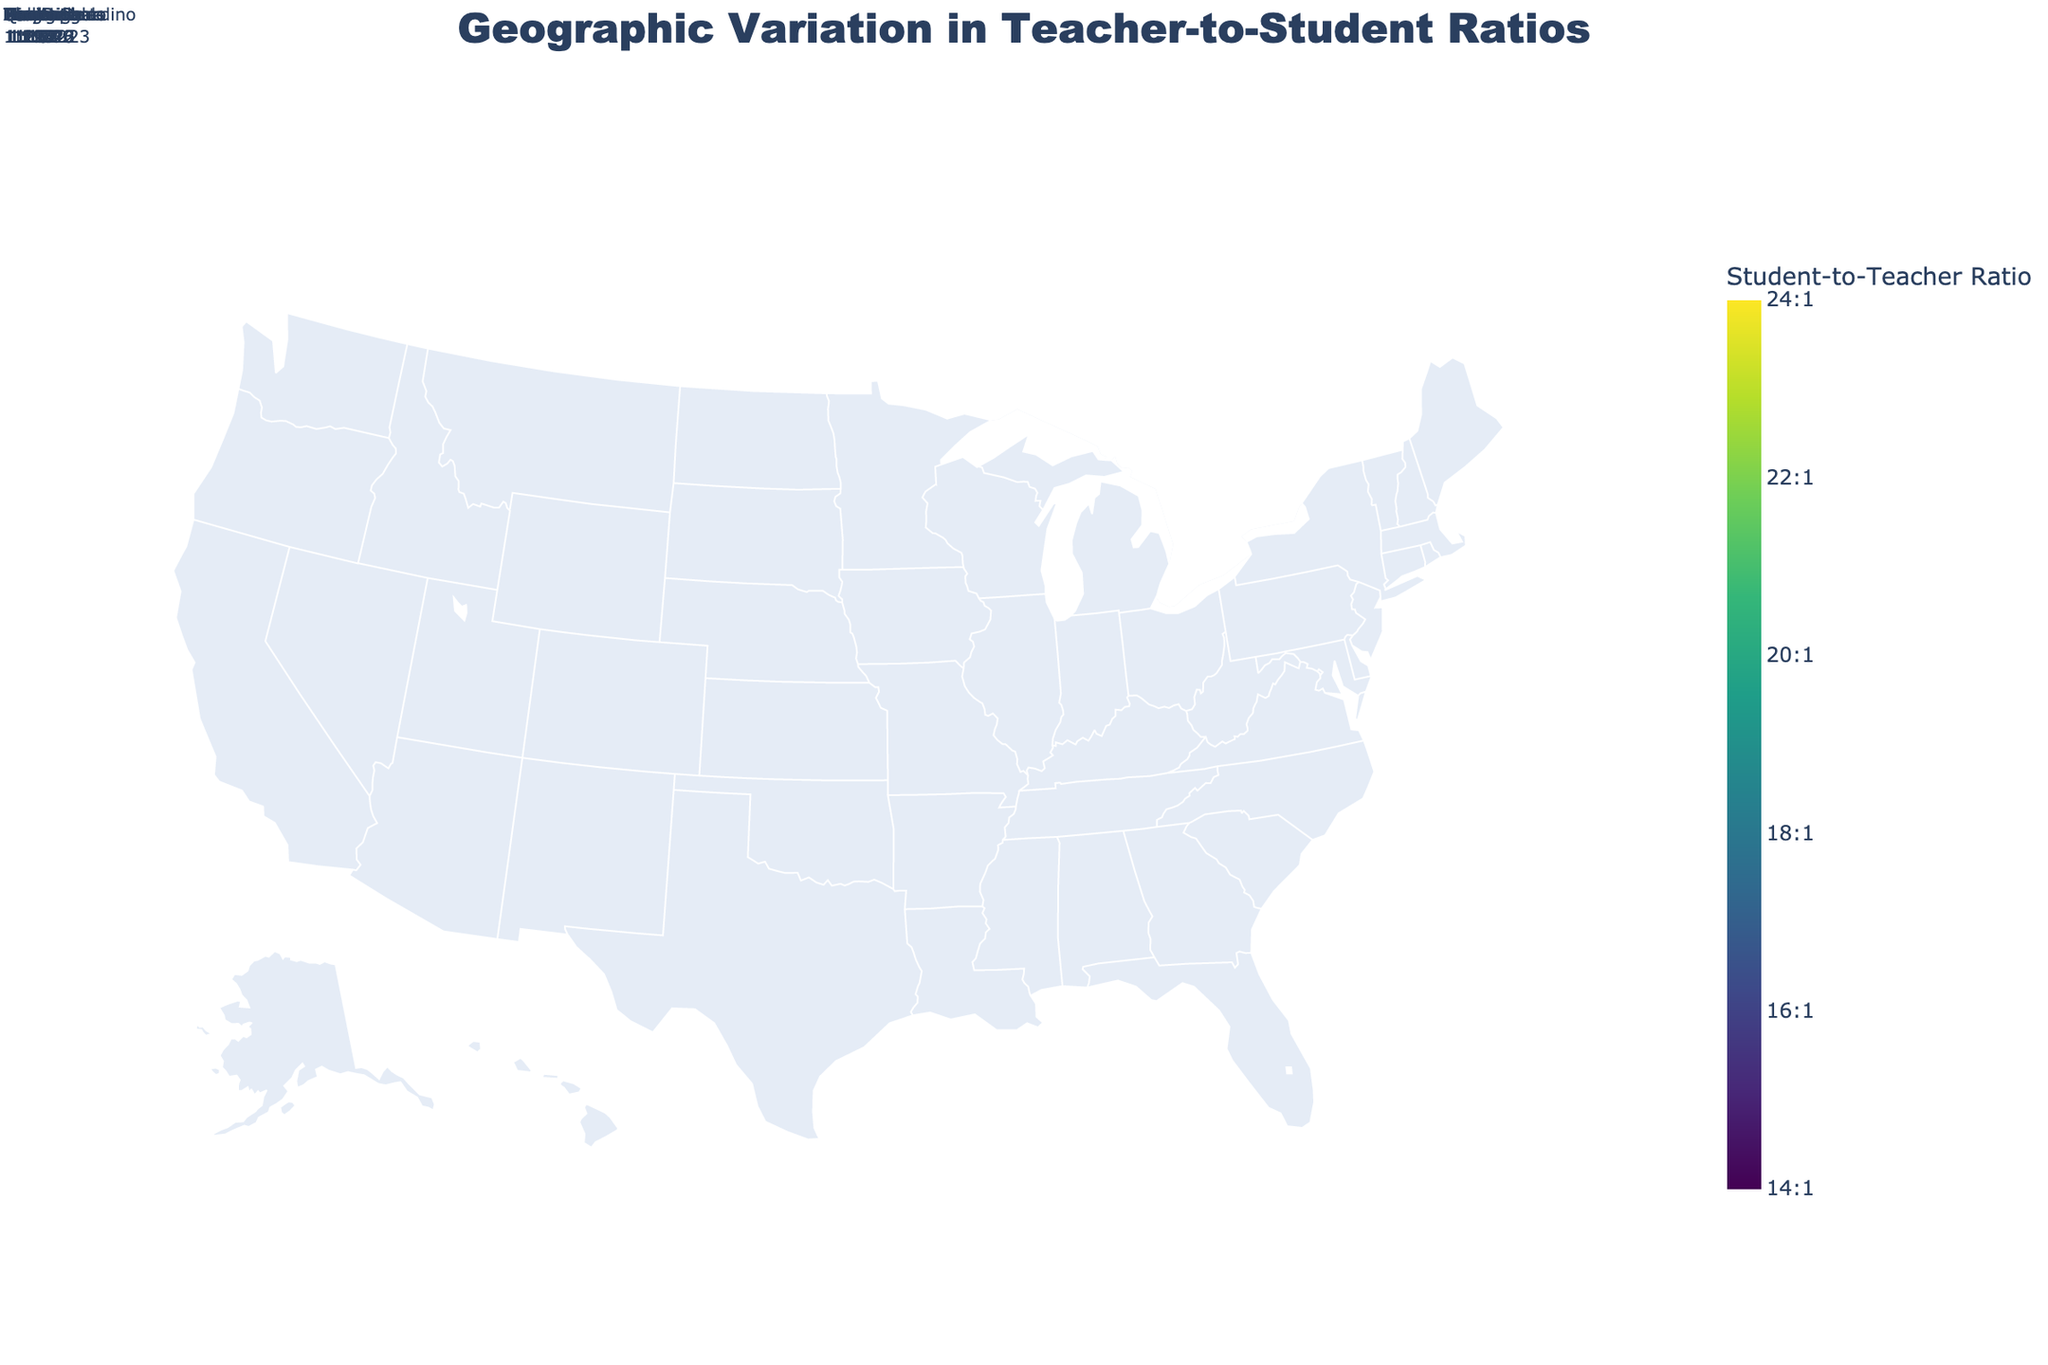Which county has the highest teacher-to-student ratio? By examining the plot and the hover information, the highest teacher-to-student ratio is identified. Orange County in California displays a ratio of 1:24, which is the highest among the displayed counties.
Answer: Orange County, California Which state is colored the darkest on the map? The color scale indicates that lower ratios are darker, so by looking for the darkest state, Texas stands out. Texas has several counties with low ratios like 1:15.
Answer: Texas What is the average teacher-to-student ratio for the counties in California? The counties listed in California have the following ratios: Los Angeles (1:23), San Diego (1:22), Orange (1:24), San Bernardino (1:23), Riverside (1:24), Santa Clara (1:20), Alameda (1:21), Sacramento (1:22). Summing these up gives (23+22+24+23+24+20+21+22) = 179. Dividing by the number of counties (8) gives an average of 22.375.
Answer: 22.375 Comparing Los Angeles County, California with Miami-Dade County, Florida, which has a lower teacher-to-student ratio? Los Angeles County, California has a ratio of 1:23, while Miami-Dade County, Florida has a ratio of 1:16. Since 16 is lower than 23, Miami-Dade has a lower ratio.
Answer: Miami-Dade County, Florida Which states have counties that exceed a teacher-to-student ratio of 1:20? By observing the ratios listed in the figure, California (Los Angeles, San Diego, Orange, San Bernardino, Riverside, Sacramento), Nevada (Clark), and Washington (King) all have counties with a ratio greater than 1:20.
Answer: California, Nevada, Washington If a new policy aims to keep the teacher-to-student ratio below 1:19, which counties fail to meet this criterion? From the list and the visual inspection of the plot, the counties exceeding 1:19 are Los Angeles (1:23), San Diego (1:22), Orange (1:24), San Bernardino (1:23), Riverside (1:24), Sacramento (1:22), Alameda (1:21), Clark (1:21).
Answer: Los Angeles, San Diego, Orange, San Bernardino, Riverside, Sacramento, Alameda, Clark 